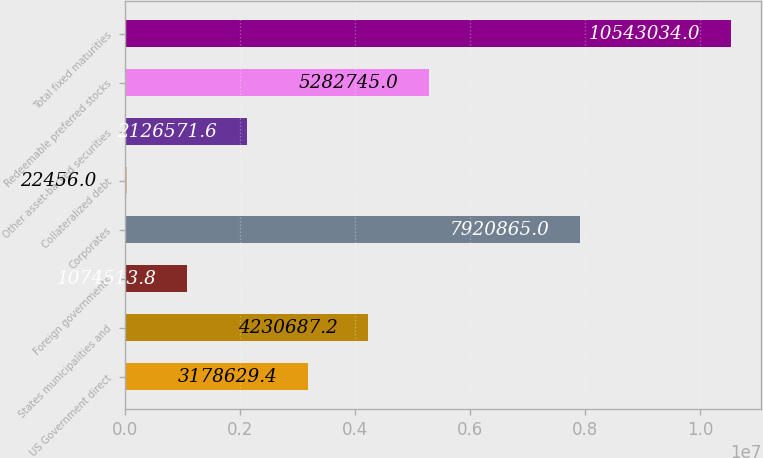Convert chart. <chart><loc_0><loc_0><loc_500><loc_500><bar_chart><fcel>US Government direct<fcel>States municipalities and<fcel>Foreign governments<fcel>Corporates<fcel>Collateralized debt<fcel>Other asset-backed securities<fcel>Redeemable preferred stocks<fcel>Total fixed maturities<nl><fcel>3.17863e+06<fcel>4.23069e+06<fcel>1.07451e+06<fcel>7.92086e+06<fcel>22456<fcel>2.12657e+06<fcel>5.28274e+06<fcel>1.0543e+07<nl></chart> 